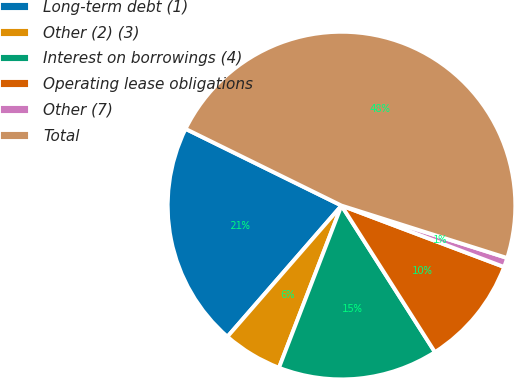<chart> <loc_0><loc_0><loc_500><loc_500><pie_chart><fcel>Long-term debt (1)<fcel>Other (2) (3)<fcel>Interest on borrowings (4)<fcel>Operating lease obligations<fcel>Other (7)<fcel>Total<nl><fcel>20.88%<fcel>5.54%<fcel>14.89%<fcel>10.22%<fcel>0.87%<fcel>47.6%<nl></chart> 